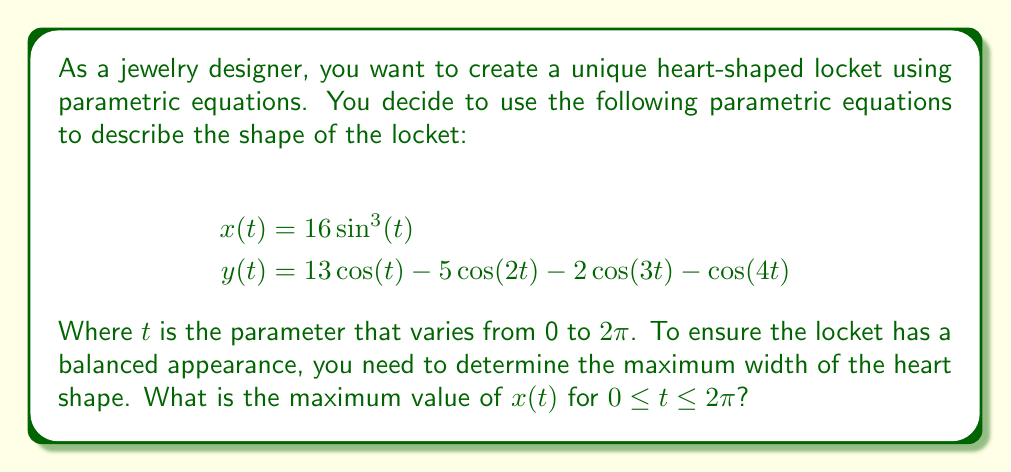Help me with this question. To find the maximum value of $x(t)$, we need to analyze the function $x(t) = 16\sin^3(t)$.

1. First, observe that $\sin(t)$ has a maximum value of 1 when $t = \frac{\pi}{2}$ or $\frac{3\pi}{2}$.

2. Since we're dealing with $\sin^3(t)$, the maximum value will occur at the same $t$ values where $\sin(t)$ is maximum.

3. Let's evaluate $x(t)$ at $t = \frac{\pi}{2}$:
   
   $$x(\frac{\pi}{2}) = 16\sin^3(\frac{\pi}{2}) = 16 \cdot 1^3 = 16$$

4. We can verify that this is indeed the maximum by considering the behavior of $\sin^3(t)$:
   - When $\sin(t)$ is positive, $\sin^3(t)$ will be smaller than or equal to $\sin(t)$.
   - When $\sin(t)$ is negative, $\sin^3(t)$ will be greater than or equal to $\sin(t)$, but still negative.

5. Therefore, the maximum value of $x(t)$ occurs when $\sin(t) = 1$, which gives us $x(t) = 16$.

This maximum width of 16 units occurs at the widest part of the heart shape, which will be crucial for determining the overall size and proportions of the locket design.
Answer: The maximum value of $x(t)$ is 16. 